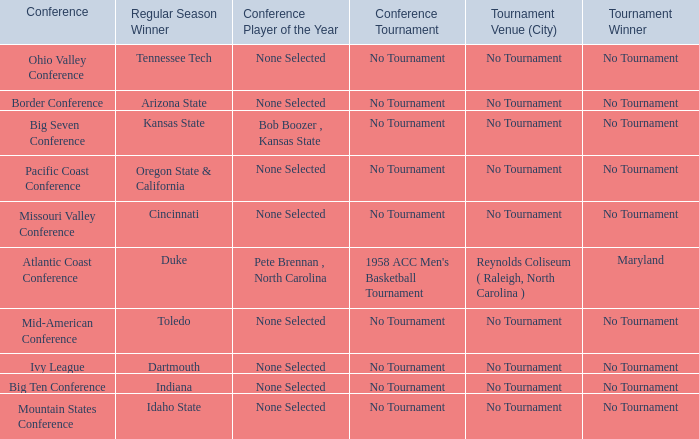What was the conference when Arizona State won the regular season? Border Conference. 